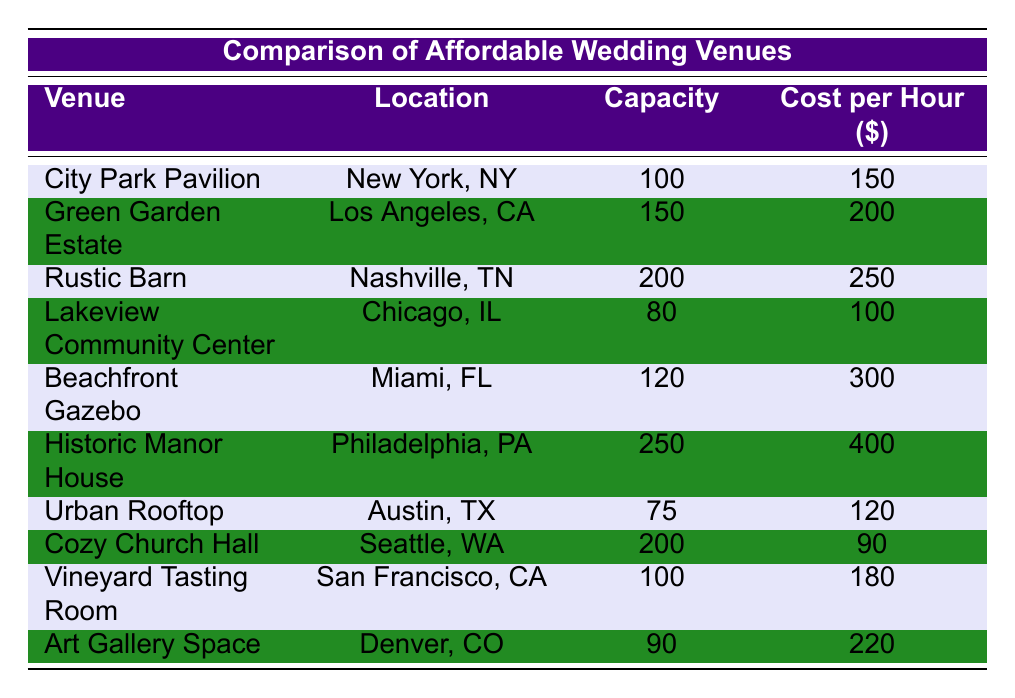What is the cost per hour for the City Park Pavilion? The cost per hour for City Park Pavilion can be found in the table under the "Cost per Hour" column next to the respective venue name. It shows 150.
Answer: 150 Which venue has the highest capacity? By examining the "Capacity" column, the highest number can be identified. The Historic Manor House has a capacity of 250, which is greater than all other venues listed.
Answer: 250 Is the Cozy Church Hall cheaper per hour than the Urban Rooftop? Comparing the "Cost per Hour" for Cozy Church Hall (90) and Urban Rooftop (120), Cozy Church Hall costs less.
Answer: Yes What is the average capacity of all venues listed? First, sum the capacities of all venues: 100 + 150 + 200 + 80 + 120 + 250 + 75 + 200 + 100 + 90 = 1365. Then divide by the number of venues, which is 10: 1365/10 = 136.5.
Answer: 136.5 How much more expensive is the Beachfront Gazebo than the Lakeview Community Center per hour? The cost for Beachfront Gazebo is 300 and for Lakeview Community Center is 100. The difference is found by subtracting 100 from 300: 300 - 100 = 200.
Answer: 200 What is the total cost per hour for the Rustic Barn and the Green Garden Estate combined? Add the cost per hour of Rustic Barn (250) and Green Garden Estate (200): 250 + 200 = 450.
Answer: 450 Is the Vineyard Tasting Room the same price as the Art Gallery Space? Compare both venues in the "Cost per Hour" column: Vineyard Tasting Room costs 180, while Art Gallery Space costs 220. They are not the same.
Answer: No What venue has the lowest capacity, and what is its cost per hour? Look at the "Capacity" column to find the lowest number, which is 75 for Urban Rooftop. The corresponding cost per hour, found in the same row, is 120.
Answer: Urban Rooftop, 120 How many venues have a cost per hour greater than 200? Check each venue's cost: Rustic Barn (250), Beachfront Gazebo (300), Historic Manor House (400), and Art Gallery Space (220). There are 4 venues.
Answer: 4 